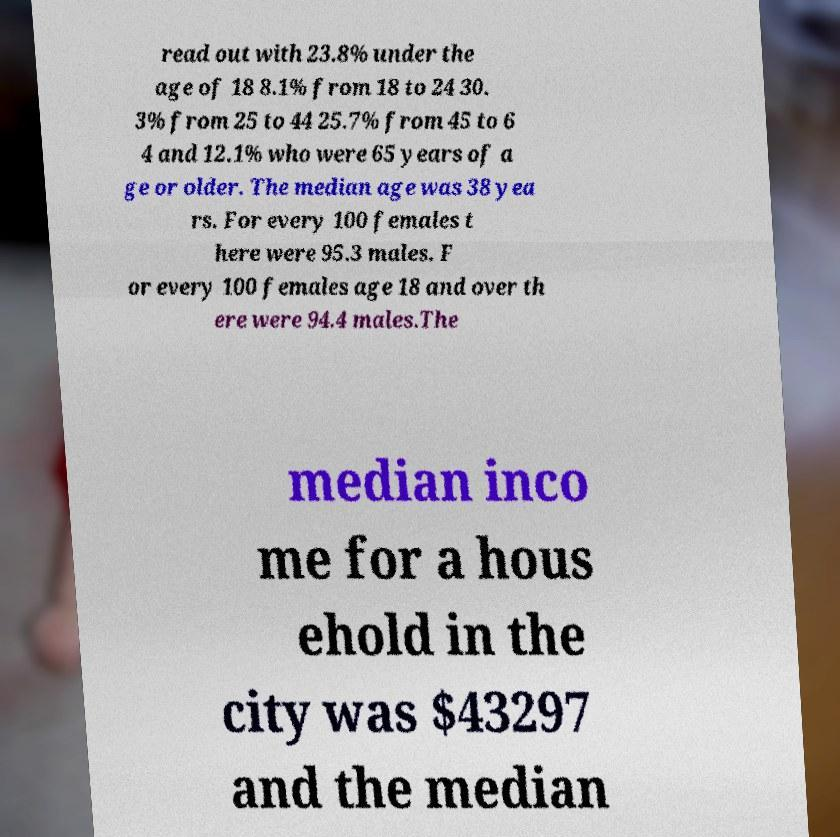Can you accurately transcribe the text from the provided image for me? read out with 23.8% under the age of 18 8.1% from 18 to 24 30. 3% from 25 to 44 25.7% from 45 to 6 4 and 12.1% who were 65 years of a ge or older. The median age was 38 yea rs. For every 100 females t here were 95.3 males. F or every 100 females age 18 and over th ere were 94.4 males.The median inco me for a hous ehold in the city was $43297 and the median 